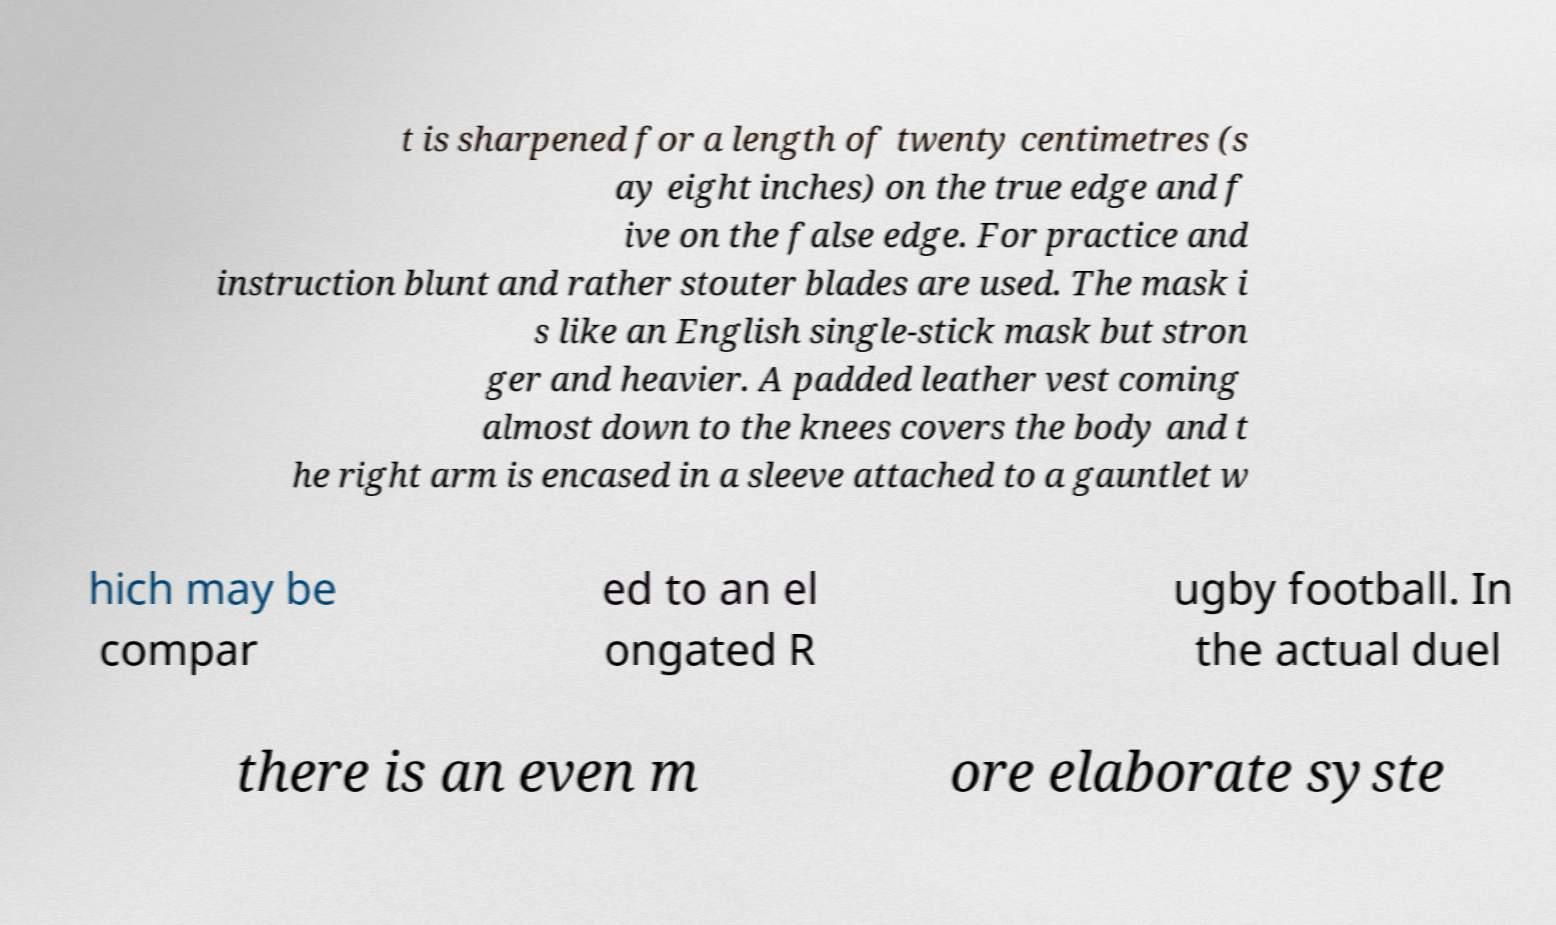I need the written content from this picture converted into text. Can you do that? t is sharpened for a length of twenty centimetres (s ay eight inches) on the true edge and f ive on the false edge. For practice and instruction blunt and rather stouter blades are used. The mask i s like an English single-stick mask but stron ger and heavier. A padded leather vest coming almost down to the knees covers the body and t he right arm is encased in a sleeve attached to a gauntlet w hich may be compar ed to an el ongated R ugby football. In the actual duel there is an even m ore elaborate syste 